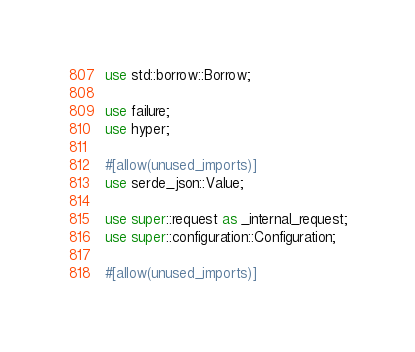Convert code to text. <code><loc_0><loc_0><loc_500><loc_500><_Rust_>use std::borrow::Borrow;

use failure;
use hyper;

#[allow(unused_imports)]
use serde_json::Value;

use super::request as _internal_request;
use super::configuration::Configuration;

#[allow(unused_imports)]</code> 